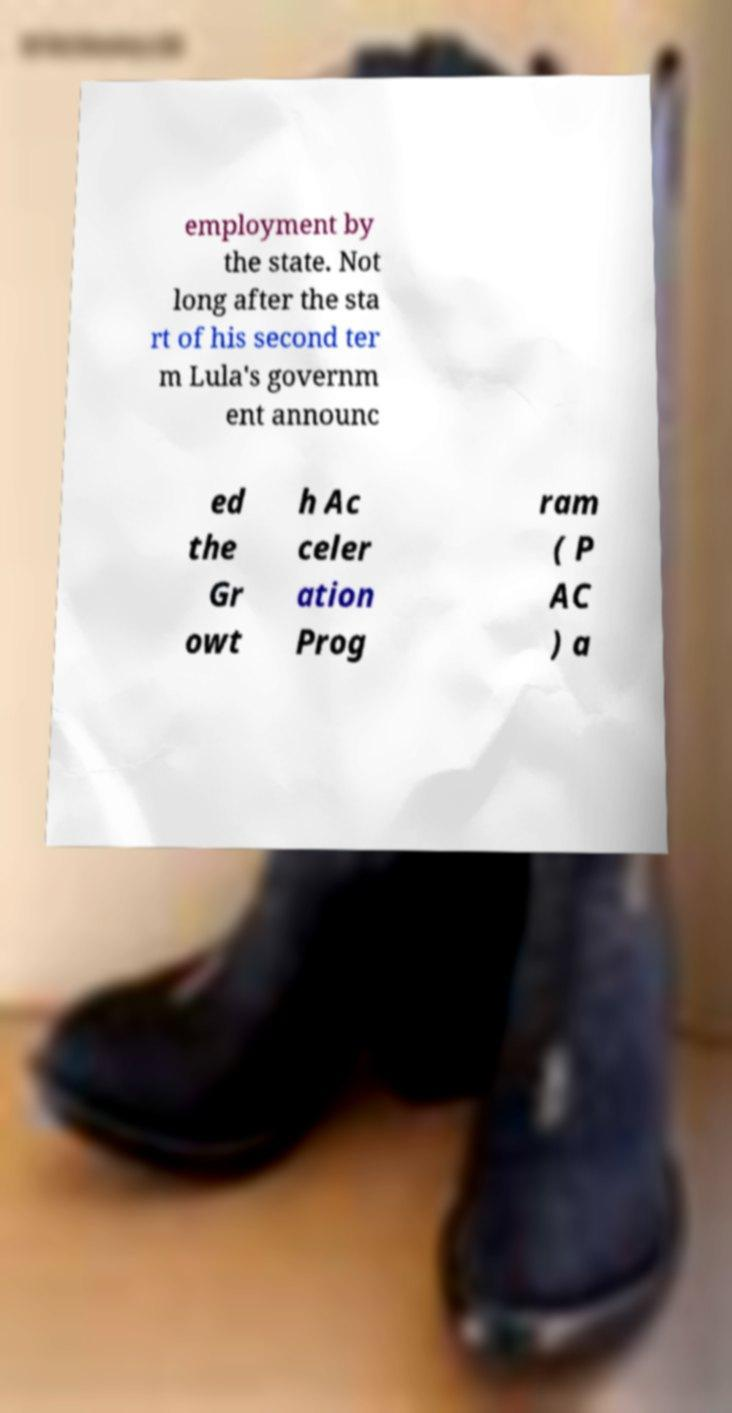I need the written content from this picture converted into text. Can you do that? employment by the state. Not long after the sta rt of his second ter m Lula's governm ent announc ed the Gr owt h Ac celer ation Prog ram ( P AC ) a 